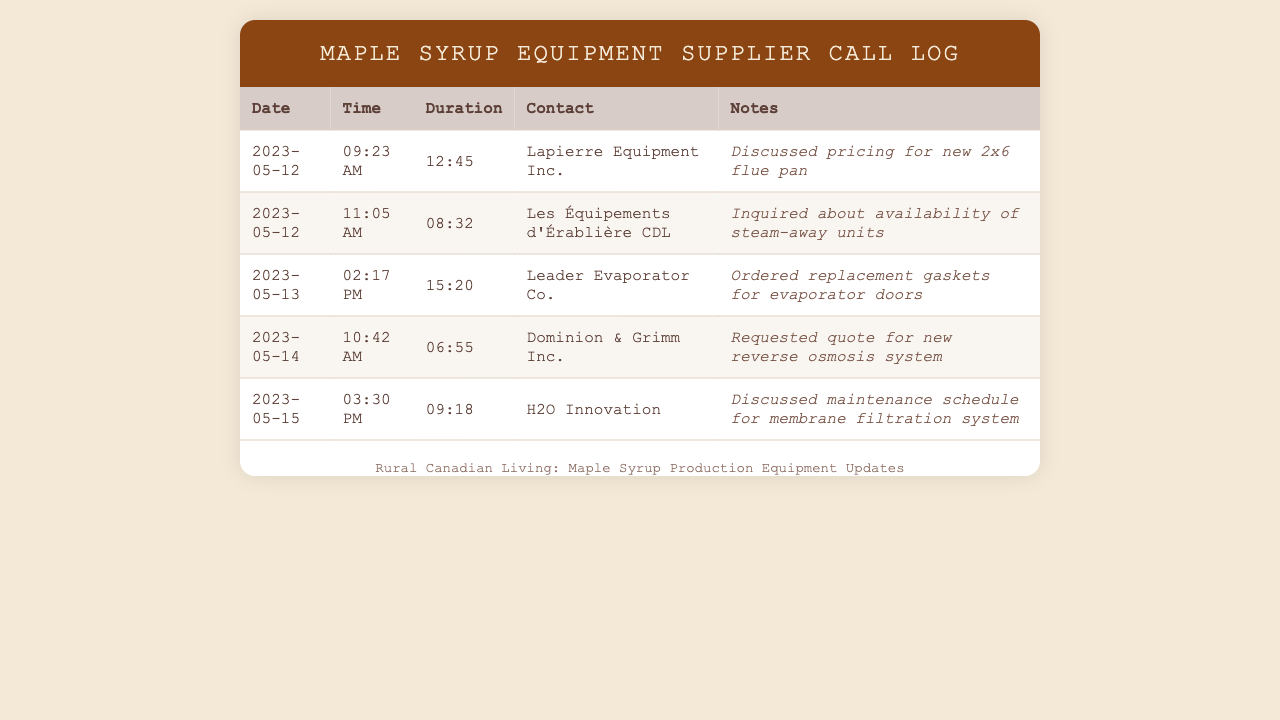What is the date of the first call? The first call in the document is recorded on May 12, 2023.
Answer: May 12, 2023 Who did the producer call on May 15, 2023? On May 15, 2023, the producer called H2O Innovation.
Answer: H2O Innovation How long was the call to Leader Evaporator Co.? The call to Leader Evaporator Co. lasted for 15 minutes and 20 seconds.
Answer: 15:20 What was requested during the call with Dominion & Grimm Inc.? During the call with Dominion & Grimm Inc., a quote was requested for a new reverse osmosis system.
Answer: Quote for new reverse osmosis system Which supplier was inquired about for steam-away units? The inquiry about steam-away units was made to Les Équipements d'Érablière CDL.
Answer: Les Équipements d'Érablière CDL What was discussed during the call on May 12, 2023, at 9:23 AM? The call on May 12, 2023, at 9:23 AM discussed pricing for new 2x6 flue pan.
Answer: Pricing for new 2x6 flue pan How many suppliers were contacted in total? A total of five suppliers were contacted in the document.
Answer: Five What type of call is this document displaying? This document displays telephone records for calls made to agricultural equipment suppliers.
Answer: Telephone records for agricultural equipment suppliers 